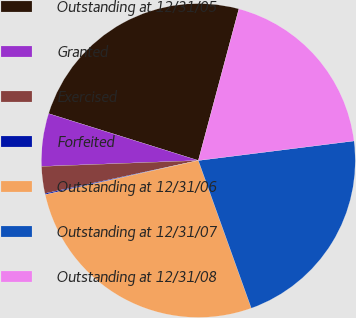<chart> <loc_0><loc_0><loc_500><loc_500><pie_chart><fcel>Outstanding at 12/31/05<fcel>Granted<fcel>Exercised<fcel>Forfeited<fcel>Outstanding at 12/31/06<fcel>Outstanding at 12/31/07<fcel>Outstanding at 12/31/08<nl><fcel>24.33%<fcel>5.43%<fcel>2.77%<fcel>0.12%<fcel>26.99%<fcel>21.51%<fcel>18.85%<nl></chart> 